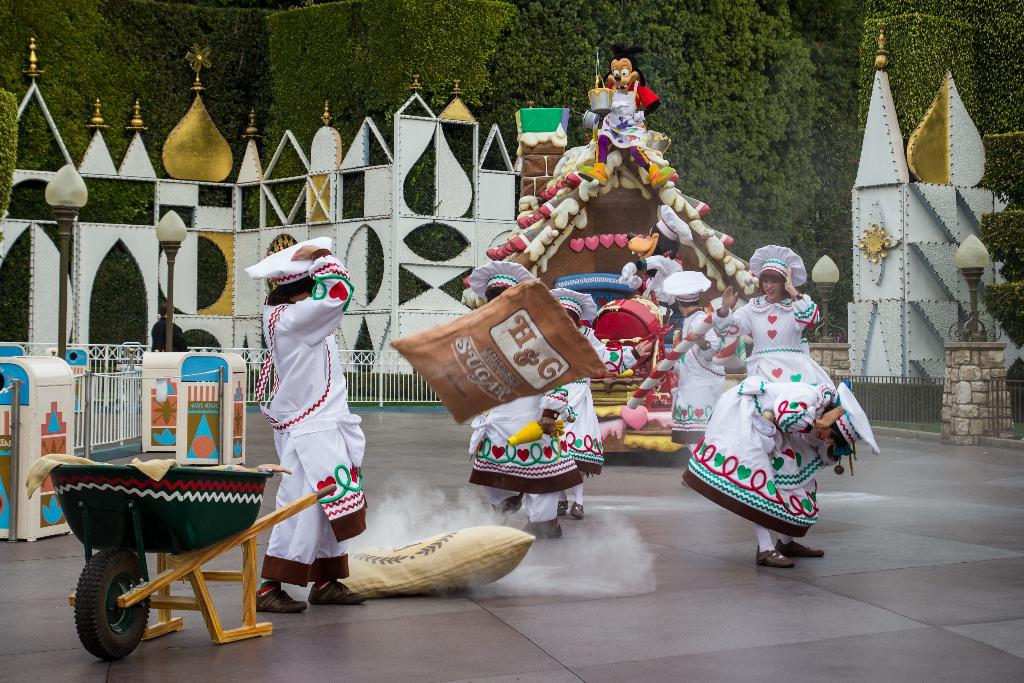What are the women in the image wearing? The women in the image are wearing white frocks. What are the women doing in the image? The women are dancing in the image. What can be seen in the background of the image? There are small castles and trees in the background of the image. What is located on the left side of the image? There is a trolley on the left side of the image. What type of copper material is used to make the scarecrow in the image? There is no scarecrow present in the image, so it is not possible to determine what type of copper material might be used. 